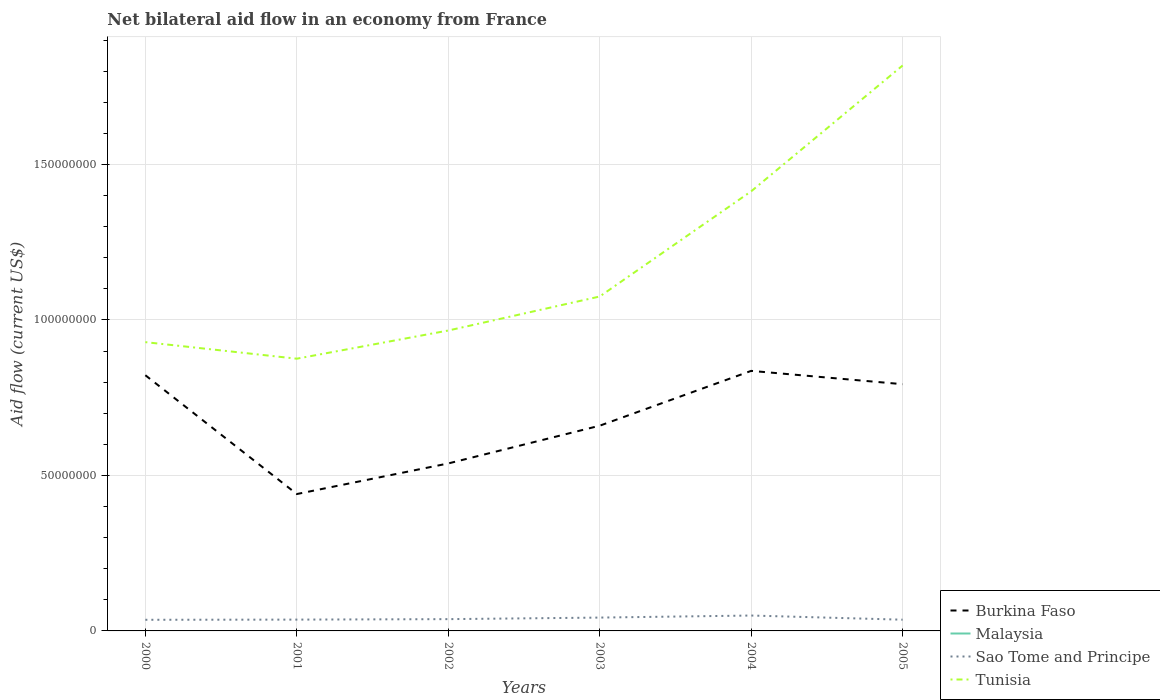How many different coloured lines are there?
Make the answer very short. 3. Is the number of lines equal to the number of legend labels?
Your response must be concise. No. Across all years, what is the maximum net bilateral aid flow in Burkina Faso?
Keep it short and to the point. 4.40e+07. What is the total net bilateral aid flow in Tunisia in the graph?
Ensure brevity in your answer.  -1.09e+07. What is the difference between the highest and the second highest net bilateral aid flow in Burkina Faso?
Provide a short and direct response. 3.96e+07. How many lines are there?
Offer a very short reply. 3. How many years are there in the graph?
Offer a terse response. 6. Does the graph contain any zero values?
Your response must be concise. Yes. Does the graph contain grids?
Make the answer very short. Yes. Where does the legend appear in the graph?
Keep it short and to the point. Bottom right. How many legend labels are there?
Your answer should be very brief. 4. How are the legend labels stacked?
Your answer should be compact. Vertical. What is the title of the graph?
Your response must be concise. Net bilateral aid flow in an economy from France. What is the label or title of the X-axis?
Keep it short and to the point. Years. What is the label or title of the Y-axis?
Your response must be concise. Aid flow (current US$). What is the Aid flow (current US$) in Burkina Faso in 2000?
Your response must be concise. 8.22e+07. What is the Aid flow (current US$) in Malaysia in 2000?
Offer a terse response. 0. What is the Aid flow (current US$) of Sao Tome and Principe in 2000?
Offer a very short reply. 3.58e+06. What is the Aid flow (current US$) in Tunisia in 2000?
Offer a terse response. 9.29e+07. What is the Aid flow (current US$) in Burkina Faso in 2001?
Your response must be concise. 4.40e+07. What is the Aid flow (current US$) in Malaysia in 2001?
Keep it short and to the point. 0. What is the Aid flow (current US$) of Sao Tome and Principe in 2001?
Ensure brevity in your answer.  3.64e+06. What is the Aid flow (current US$) of Tunisia in 2001?
Make the answer very short. 8.76e+07. What is the Aid flow (current US$) in Burkina Faso in 2002?
Keep it short and to the point. 5.39e+07. What is the Aid flow (current US$) in Malaysia in 2002?
Ensure brevity in your answer.  0. What is the Aid flow (current US$) of Sao Tome and Principe in 2002?
Provide a succinct answer. 3.79e+06. What is the Aid flow (current US$) of Tunisia in 2002?
Offer a terse response. 9.66e+07. What is the Aid flow (current US$) of Burkina Faso in 2003?
Offer a terse response. 6.60e+07. What is the Aid flow (current US$) in Malaysia in 2003?
Keep it short and to the point. 0. What is the Aid flow (current US$) of Sao Tome and Principe in 2003?
Provide a short and direct response. 4.29e+06. What is the Aid flow (current US$) of Tunisia in 2003?
Give a very brief answer. 1.08e+08. What is the Aid flow (current US$) of Burkina Faso in 2004?
Make the answer very short. 8.36e+07. What is the Aid flow (current US$) in Sao Tome and Principe in 2004?
Your response must be concise. 4.95e+06. What is the Aid flow (current US$) of Tunisia in 2004?
Your answer should be very brief. 1.41e+08. What is the Aid flow (current US$) of Burkina Faso in 2005?
Make the answer very short. 7.94e+07. What is the Aid flow (current US$) of Malaysia in 2005?
Offer a terse response. 0. What is the Aid flow (current US$) of Sao Tome and Principe in 2005?
Offer a terse response. 3.61e+06. What is the Aid flow (current US$) in Tunisia in 2005?
Make the answer very short. 1.82e+08. Across all years, what is the maximum Aid flow (current US$) of Burkina Faso?
Offer a very short reply. 8.36e+07. Across all years, what is the maximum Aid flow (current US$) of Sao Tome and Principe?
Your answer should be compact. 4.95e+06. Across all years, what is the maximum Aid flow (current US$) in Tunisia?
Keep it short and to the point. 1.82e+08. Across all years, what is the minimum Aid flow (current US$) in Burkina Faso?
Provide a succinct answer. 4.40e+07. Across all years, what is the minimum Aid flow (current US$) of Sao Tome and Principe?
Provide a succinct answer. 3.58e+06. Across all years, what is the minimum Aid flow (current US$) of Tunisia?
Offer a terse response. 8.76e+07. What is the total Aid flow (current US$) in Burkina Faso in the graph?
Your answer should be very brief. 4.09e+08. What is the total Aid flow (current US$) of Malaysia in the graph?
Your answer should be compact. 0. What is the total Aid flow (current US$) of Sao Tome and Principe in the graph?
Your response must be concise. 2.39e+07. What is the total Aid flow (current US$) of Tunisia in the graph?
Ensure brevity in your answer.  7.08e+08. What is the difference between the Aid flow (current US$) in Burkina Faso in 2000 and that in 2001?
Keep it short and to the point. 3.82e+07. What is the difference between the Aid flow (current US$) in Sao Tome and Principe in 2000 and that in 2001?
Ensure brevity in your answer.  -6.00e+04. What is the difference between the Aid flow (current US$) of Tunisia in 2000 and that in 2001?
Ensure brevity in your answer.  5.32e+06. What is the difference between the Aid flow (current US$) in Burkina Faso in 2000 and that in 2002?
Give a very brief answer. 2.84e+07. What is the difference between the Aid flow (current US$) in Tunisia in 2000 and that in 2002?
Give a very brief answer. -3.74e+06. What is the difference between the Aid flow (current US$) in Burkina Faso in 2000 and that in 2003?
Give a very brief answer. 1.62e+07. What is the difference between the Aid flow (current US$) of Sao Tome and Principe in 2000 and that in 2003?
Provide a succinct answer. -7.10e+05. What is the difference between the Aid flow (current US$) in Tunisia in 2000 and that in 2003?
Your answer should be very brief. -1.47e+07. What is the difference between the Aid flow (current US$) of Burkina Faso in 2000 and that in 2004?
Keep it short and to the point. -1.40e+06. What is the difference between the Aid flow (current US$) of Sao Tome and Principe in 2000 and that in 2004?
Give a very brief answer. -1.37e+06. What is the difference between the Aid flow (current US$) of Tunisia in 2000 and that in 2004?
Offer a terse response. -4.85e+07. What is the difference between the Aid flow (current US$) of Burkina Faso in 2000 and that in 2005?
Your response must be concise. 2.88e+06. What is the difference between the Aid flow (current US$) of Sao Tome and Principe in 2000 and that in 2005?
Make the answer very short. -3.00e+04. What is the difference between the Aid flow (current US$) in Tunisia in 2000 and that in 2005?
Provide a succinct answer. -8.90e+07. What is the difference between the Aid flow (current US$) of Burkina Faso in 2001 and that in 2002?
Provide a short and direct response. -9.84e+06. What is the difference between the Aid flow (current US$) of Sao Tome and Principe in 2001 and that in 2002?
Offer a terse response. -1.50e+05. What is the difference between the Aid flow (current US$) in Tunisia in 2001 and that in 2002?
Make the answer very short. -9.06e+06. What is the difference between the Aid flow (current US$) in Burkina Faso in 2001 and that in 2003?
Keep it short and to the point. -2.20e+07. What is the difference between the Aid flow (current US$) in Sao Tome and Principe in 2001 and that in 2003?
Your answer should be compact. -6.50e+05. What is the difference between the Aid flow (current US$) in Tunisia in 2001 and that in 2003?
Give a very brief answer. -2.00e+07. What is the difference between the Aid flow (current US$) of Burkina Faso in 2001 and that in 2004?
Provide a short and direct response. -3.96e+07. What is the difference between the Aid flow (current US$) in Sao Tome and Principe in 2001 and that in 2004?
Offer a terse response. -1.31e+06. What is the difference between the Aid flow (current US$) of Tunisia in 2001 and that in 2004?
Give a very brief answer. -5.38e+07. What is the difference between the Aid flow (current US$) in Burkina Faso in 2001 and that in 2005?
Provide a succinct answer. -3.53e+07. What is the difference between the Aid flow (current US$) of Tunisia in 2001 and that in 2005?
Your answer should be compact. -9.43e+07. What is the difference between the Aid flow (current US$) in Burkina Faso in 2002 and that in 2003?
Make the answer very short. -1.21e+07. What is the difference between the Aid flow (current US$) in Sao Tome and Principe in 2002 and that in 2003?
Give a very brief answer. -5.00e+05. What is the difference between the Aid flow (current US$) in Tunisia in 2002 and that in 2003?
Offer a terse response. -1.09e+07. What is the difference between the Aid flow (current US$) in Burkina Faso in 2002 and that in 2004?
Your response must be concise. -2.98e+07. What is the difference between the Aid flow (current US$) of Sao Tome and Principe in 2002 and that in 2004?
Provide a short and direct response. -1.16e+06. What is the difference between the Aid flow (current US$) of Tunisia in 2002 and that in 2004?
Keep it short and to the point. -4.48e+07. What is the difference between the Aid flow (current US$) of Burkina Faso in 2002 and that in 2005?
Give a very brief answer. -2.55e+07. What is the difference between the Aid flow (current US$) of Tunisia in 2002 and that in 2005?
Provide a short and direct response. -8.52e+07. What is the difference between the Aid flow (current US$) of Burkina Faso in 2003 and that in 2004?
Offer a terse response. -1.76e+07. What is the difference between the Aid flow (current US$) of Sao Tome and Principe in 2003 and that in 2004?
Keep it short and to the point. -6.60e+05. What is the difference between the Aid flow (current US$) in Tunisia in 2003 and that in 2004?
Your answer should be compact. -3.38e+07. What is the difference between the Aid flow (current US$) of Burkina Faso in 2003 and that in 2005?
Offer a very short reply. -1.34e+07. What is the difference between the Aid flow (current US$) in Sao Tome and Principe in 2003 and that in 2005?
Provide a succinct answer. 6.80e+05. What is the difference between the Aid flow (current US$) of Tunisia in 2003 and that in 2005?
Make the answer very short. -7.43e+07. What is the difference between the Aid flow (current US$) of Burkina Faso in 2004 and that in 2005?
Your answer should be very brief. 4.28e+06. What is the difference between the Aid flow (current US$) in Sao Tome and Principe in 2004 and that in 2005?
Offer a very short reply. 1.34e+06. What is the difference between the Aid flow (current US$) in Tunisia in 2004 and that in 2005?
Offer a very short reply. -4.05e+07. What is the difference between the Aid flow (current US$) of Burkina Faso in 2000 and the Aid flow (current US$) of Sao Tome and Principe in 2001?
Ensure brevity in your answer.  7.86e+07. What is the difference between the Aid flow (current US$) of Burkina Faso in 2000 and the Aid flow (current US$) of Tunisia in 2001?
Provide a short and direct response. -5.32e+06. What is the difference between the Aid flow (current US$) in Sao Tome and Principe in 2000 and the Aid flow (current US$) in Tunisia in 2001?
Provide a short and direct response. -8.40e+07. What is the difference between the Aid flow (current US$) of Burkina Faso in 2000 and the Aid flow (current US$) of Sao Tome and Principe in 2002?
Your response must be concise. 7.84e+07. What is the difference between the Aid flow (current US$) in Burkina Faso in 2000 and the Aid flow (current US$) in Tunisia in 2002?
Your answer should be compact. -1.44e+07. What is the difference between the Aid flow (current US$) in Sao Tome and Principe in 2000 and the Aid flow (current US$) in Tunisia in 2002?
Your answer should be compact. -9.30e+07. What is the difference between the Aid flow (current US$) of Burkina Faso in 2000 and the Aid flow (current US$) of Sao Tome and Principe in 2003?
Provide a succinct answer. 7.79e+07. What is the difference between the Aid flow (current US$) in Burkina Faso in 2000 and the Aid flow (current US$) in Tunisia in 2003?
Your response must be concise. -2.53e+07. What is the difference between the Aid flow (current US$) in Sao Tome and Principe in 2000 and the Aid flow (current US$) in Tunisia in 2003?
Provide a succinct answer. -1.04e+08. What is the difference between the Aid flow (current US$) in Burkina Faso in 2000 and the Aid flow (current US$) in Sao Tome and Principe in 2004?
Ensure brevity in your answer.  7.73e+07. What is the difference between the Aid flow (current US$) of Burkina Faso in 2000 and the Aid flow (current US$) of Tunisia in 2004?
Give a very brief answer. -5.92e+07. What is the difference between the Aid flow (current US$) of Sao Tome and Principe in 2000 and the Aid flow (current US$) of Tunisia in 2004?
Ensure brevity in your answer.  -1.38e+08. What is the difference between the Aid flow (current US$) of Burkina Faso in 2000 and the Aid flow (current US$) of Sao Tome and Principe in 2005?
Give a very brief answer. 7.86e+07. What is the difference between the Aid flow (current US$) in Burkina Faso in 2000 and the Aid flow (current US$) in Tunisia in 2005?
Offer a terse response. -9.96e+07. What is the difference between the Aid flow (current US$) of Sao Tome and Principe in 2000 and the Aid flow (current US$) of Tunisia in 2005?
Give a very brief answer. -1.78e+08. What is the difference between the Aid flow (current US$) of Burkina Faso in 2001 and the Aid flow (current US$) of Sao Tome and Principe in 2002?
Keep it short and to the point. 4.02e+07. What is the difference between the Aid flow (current US$) in Burkina Faso in 2001 and the Aid flow (current US$) in Tunisia in 2002?
Your response must be concise. -5.26e+07. What is the difference between the Aid flow (current US$) of Sao Tome and Principe in 2001 and the Aid flow (current US$) of Tunisia in 2002?
Make the answer very short. -9.30e+07. What is the difference between the Aid flow (current US$) of Burkina Faso in 2001 and the Aid flow (current US$) of Sao Tome and Principe in 2003?
Offer a terse response. 3.97e+07. What is the difference between the Aid flow (current US$) of Burkina Faso in 2001 and the Aid flow (current US$) of Tunisia in 2003?
Make the answer very short. -6.35e+07. What is the difference between the Aid flow (current US$) in Sao Tome and Principe in 2001 and the Aid flow (current US$) in Tunisia in 2003?
Your response must be concise. -1.04e+08. What is the difference between the Aid flow (current US$) of Burkina Faso in 2001 and the Aid flow (current US$) of Sao Tome and Principe in 2004?
Your response must be concise. 3.91e+07. What is the difference between the Aid flow (current US$) of Burkina Faso in 2001 and the Aid flow (current US$) of Tunisia in 2004?
Ensure brevity in your answer.  -9.74e+07. What is the difference between the Aid flow (current US$) of Sao Tome and Principe in 2001 and the Aid flow (current US$) of Tunisia in 2004?
Offer a terse response. -1.38e+08. What is the difference between the Aid flow (current US$) of Burkina Faso in 2001 and the Aid flow (current US$) of Sao Tome and Principe in 2005?
Your answer should be compact. 4.04e+07. What is the difference between the Aid flow (current US$) of Burkina Faso in 2001 and the Aid flow (current US$) of Tunisia in 2005?
Offer a terse response. -1.38e+08. What is the difference between the Aid flow (current US$) of Sao Tome and Principe in 2001 and the Aid flow (current US$) of Tunisia in 2005?
Offer a terse response. -1.78e+08. What is the difference between the Aid flow (current US$) in Burkina Faso in 2002 and the Aid flow (current US$) in Sao Tome and Principe in 2003?
Ensure brevity in your answer.  4.96e+07. What is the difference between the Aid flow (current US$) of Burkina Faso in 2002 and the Aid flow (current US$) of Tunisia in 2003?
Your response must be concise. -5.37e+07. What is the difference between the Aid flow (current US$) of Sao Tome and Principe in 2002 and the Aid flow (current US$) of Tunisia in 2003?
Ensure brevity in your answer.  -1.04e+08. What is the difference between the Aid flow (current US$) of Burkina Faso in 2002 and the Aid flow (current US$) of Sao Tome and Principe in 2004?
Provide a succinct answer. 4.89e+07. What is the difference between the Aid flow (current US$) of Burkina Faso in 2002 and the Aid flow (current US$) of Tunisia in 2004?
Offer a very short reply. -8.75e+07. What is the difference between the Aid flow (current US$) in Sao Tome and Principe in 2002 and the Aid flow (current US$) in Tunisia in 2004?
Make the answer very short. -1.38e+08. What is the difference between the Aid flow (current US$) in Burkina Faso in 2002 and the Aid flow (current US$) in Sao Tome and Principe in 2005?
Your answer should be very brief. 5.02e+07. What is the difference between the Aid flow (current US$) of Burkina Faso in 2002 and the Aid flow (current US$) of Tunisia in 2005?
Your response must be concise. -1.28e+08. What is the difference between the Aid flow (current US$) of Sao Tome and Principe in 2002 and the Aid flow (current US$) of Tunisia in 2005?
Keep it short and to the point. -1.78e+08. What is the difference between the Aid flow (current US$) in Burkina Faso in 2003 and the Aid flow (current US$) in Sao Tome and Principe in 2004?
Provide a short and direct response. 6.10e+07. What is the difference between the Aid flow (current US$) of Burkina Faso in 2003 and the Aid flow (current US$) of Tunisia in 2004?
Offer a very short reply. -7.54e+07. What is the difference between the Aid flow (current US$) in Sao Tome and Principe in 2003 and the Aid flow (current US$) in Tunisia in 2004?
Ensure brevity in your answer.  -1.37e+08. What is the difference between the Aid flow (current US$) in Burkina Faso in 2003 and the Aid flow (current US$) in Sao Tome and Principe in 2005?
Make the answer very short. 6.24e+07. What is the difference between the Aid flow (current US$) of Burkina Faso in 2003 and the Aid flow (current US$) of Tunisia in 2005?
Your answer should be compact. -1.16e+08. What is the difference between the Aid flow (current US$) of Sao Tome and Principe in 2003 and the Aid flow (current US$) of Tunisia in 2005?
Offer a very short reply. -1.78e+08. What is the difference between the Aid flow (current US$) of Burkina Faso in 2004 and the Aid flow (current US$) of Sao Tome and Principe in 2005?
Keep it short and to the point. 8.00e+07. What is the difference between the Aid flow (current US$) of Burkina Faso in 2004 and the Aid flow (current US$) of Tunisia in 2005?
Your answer should be very brief. -9.82e+07. What is the difference between the Aid flow (current US$) in Sao Tome and Principe in 2004 and the Aid flow (current US$) in Tunisia in 2005?
Make the answer very short. -1.77e+08. What is the average Aid flow (current US$) of Burkina Faso per year?
Your answer should be very brief. 6.82e+07. What is the average Aid flow (current US$) of Sao Tome and Principe per year?
Offer a very short reply. 3.98e+06. What is the average Aid flow (current US$) of Tunisia per year?
Keep it short and to the point. 1.18e+08. In the year 2000, what is the difference between the Aid flow (current US$) in Burkina Faso and Aid flow (current US$) in Sao Tome and Principe?
Your response must be concise. 7.86e+07. In the year 2000, what is the difference between the Aid flow (current US$) of Burkina Faso and Aid flow (current US$) of Tunisia?
Provide a succinct answer. -1.06e+07. In the year 2000, what is the difference between the Aid flow (current US$) in Sao Tome and Principe and Aid flow (current US$) in Tunisia?
Provide a succinct answer. -8.93e+07. In the year 2001, what is the difference between the Aid flow (current US$) in Burkina Faso and Aid flow (current US$) in Sao Tome and Principe?
Ensure brevity in your answer.  4.04e+07. In the year 2001, what is the difference between the Aid flow (current US$) in Burkina Faso and Aid flow (current US$) in Tunisia?
Ensure brevity in your answer.  -4.35e+07. In the year 2001, what is the difference between the Aid flow (current US$) of Sao Tome and Principe and Aid flow (current US$) of Tunisia?
Your response must be concise. -8.39e+07. In the year 2002, what is the difference between the Aid flow (current US$) in Burkina Faso and Aid flow (current US$) in Sao Tome and Principe?
Keep it short and to the point. 5.01e+07. In the year 2002, what is the difference between the Aid flow (current US$) in Burkina Faso and Aid flow (current US$) in Tunisia?
Ensure brevity in your answer.  -4.28e+07. In the year 2002, what is the difference between the Aid flow (current US$) in Sao Tome and Principe and Aid flow (current US$) in Tunisia?
Your answer should be compact. -9.28e+07. In the year 2003, what is the difference between the Aid flow (current US$) of Burkina Faso and Aid flow (current US$) of Sao Tome and Principe?
Give a very brief answer. 6.17e+07. In the year 2003, what is the difference between the Aid flow (current US$) of Burkina Faso and Aid flow (current US$) of Tunisia?
Offer a terse response. -4.16e+07. In the year 2003, what is the difference between the Aid flow (current US$) in Sao Tome and Principe and Aid flow (current US$) in Tunisia?
Your response must be concise. -1.03e+08. In the year 2004, what is the difference between the Aid flow (current US$) of Burkina Faso and Aid flow (current US$) of Sao Tome and Principe?
Ensure brevity in your answer.  7.87e+07. In the year 2004, what is the difference between the Aid flow (current US$) of Burkina Faso and Aid flow (current US$) of Tunisia?
Provide a succinct answer. -5.78e+07. In the year 2004, what is the difference between the Aid flow (current US$) of Sao Tome and Principe and Aid flow (current US$) of Tunisia?
Your answer should be very brief. -1.36e+08. In the year 2005, what is the difference between the Aid flow (current US$) of Burkina Faso and Aid flow (current US$) of Sao Tome and Principe?
Ensure brevity in your answer.  7.57e+07. In the year 2005, what is the difference between the Aid flow (current US$) in Burkina Faso and Aid flow (current US$) in Tunisia?
Provide a succinct answer. -1.02e+08. In the year 2005, what is the difference between the Aid flow (current US$) in Sao Tome and Principe and Aid flow (current US$) in Tunisia?
Provide a short and direct response. -1.78e+08. What is the ratio of the Aid flow (current US$) in Burkina Faso in 2000 to that in 2001?
Ensure brevity in your answer.  1.87. What is the ratio of the Aid flow (current US$) of Sao Tome and Principe in 2000 to that in 2001?
Your response must be concise. 0.98. What is the ratio of the Aid flow (current US$) of Tunisia in 2000 to that in 2001?
Offer a terse response. 1.06. What is the ratio of the Aid flow (current US$) of Burkina Faso in 2000 to that in 2002?
Provide a succinct answer. 1.53. What is the ratio of the Aid flow (current US$) of Sao Tome and Principe in 2000 to that in 2002?
Offer a very short reply. 0.94. What is the ratio of the Aid flow (current US$) of Tunisia in 2000 to that in 2002?
Your answer should be very brief. 0.96. What is the ratio of the Aid flow (current US$) of Burkina Faso in 2000 to that in 2003?
Provide a short and direct response. 1.25. What is the ratio of the Aid flow (current US$) in Sao Tome and Principe in 2000 to that in 2003?
Your answer should be compact. 0.83. What is the ratio of the Aid flow (current US$) of Tunisia in 2000 to that in 2003?
Your response must be concise. 0.86. What is the ratio of the Aid flow (current US$) of Burkina Faso in 2000 to that in 2004?
Provide a short and direct response. 0.98. What is the ratio of the Aid flow (current US$) of Sao Tome and Principe in 2000 to that in 2004?
Keep it short and to the point. 0.72. What is the ratio of the Aid flow (current US$) of Tunisia in 2000 to that in 2004?
Provide a succinct answer. 0.66. What is the ratio of the Aid flow (current US$) in Burkina Faso in 2000 to that in 2005?
Give a very brief answer. 1.04. What is the ratio of the Aid flow (current US$) in Tunisia in 2000 to that in 2005?
Offer a terse response. 0.51. What is the ratio of the Aid flow (current US$) in Burkina Faso in 2001 to that in 2002?
Make the answer very short. 0.82. What is the ratio of the Aid flow (current US$) in Sao Tome and Principe in 2001 to that in 2002?
Ensure brevity in your answer.  0.96. What is the ratio of the Aid flow (current US$) of Tunisia in 2001 to that in 2002?
Your response must be concise. 0.91. What is the ratio of the Aid flow (current US$) of Burkina Faso in 2001 to that in 2003?
Ensure brevity in your answer.  0.67. What is the ratio of the Aid flow (current US$) in Sao Tome and Principe in 2001 to that in 2003?
Make the answer very short. 0.85. What is the ratio of the Aid flow (current US$) in Tunisia in 2001 to that in 2003?
Make the answer very short. 0.81. What is the ratio of the Aid flow (current US$) of Burkina Faso in 2001 to that in 2004?
Make the answer very short. 0.53. What is the ratio of the Aid flow (current US$) of Sao Tome and Principe in 2001 to that in 2004?
Ensure brevity in your answer.  0.74. What is the ratio of the Aid flow (current US$) of Tunisia in 2001 to that in 2004?
Offer a very short reply. 0.62. What is the ratio of the Aid flow (current US$) of Burkina Faso in 2001 to that in 2005?
Give a very brief answer. 0.55. What is the ratio of the Aid flow (current US$) of Sao Tome and Principe in 2001 to that in 2005?
Offer a terse response. 1.01. What is the ratio of the Aid flow (current US$) in Tunisia in 2001 to that in 2005?
Offer a terse response. 0.48. What is the ratio of the Aid flow (current US$) of Burkina Faso in 2002 to that in 2003?
Your answer should be very brief. 0.82. What is the ratio of the Aid flow (current US$) of Sao Tome and Principe in 2002 to that in 2003?
Ensure brevity in your answer.  0.88. What is the ratio of the Aid flow (current US$) of Tunisia in 2002 to that in 2003?
Your answer should be very brief. 0.9. What is the ratio of the Aid flow (current US$) of Burkina Faso in 2002 to that in 2004?
Your response must be concise. 0.64. What is the ratio of the Aid flow (current US$) in Sao Tome and Principe in 2002 to that in 2004?
Ensure brevity in your answer.  0.77. What is the ratio of the Aid flow (current US$) in Tunisia in 2002 to that in 2004?
Ensure brevity in your answer.  0.68. What is the ratio of the Aid flow (current US$) in Burkina Faso in 2002 to that in 2005?
Provide a succinct answer. 0.68. What is the ratio of the Aid flow (current US$) in Sao Tome and Principe in 2002 to that in 2005?
Your response must be concise. 1.05. What is the ratio of the Aid flow (current US$) in Tunisia in 2002 to that in 2005?
Provide a short and direct response. 0.53. What is the ratio of the Aid flow (current US$) in Burkina Faso in 2003 to that in 2004?
Make the answer very short. 0.79. What is the ratio of the Aid flow (current US$) in Sao Tome and Principe in 2003 to that in 2004?
Provide a succinct answer. 0.87. What is the ratio of the Aid flow (current US$) of Tunisia in 2003 to that in 2004?
Provide a short and direct response. 0.76. What is the ratio of the Aid flow (current US$) in Burkina Faso in 2003 to that in 2005?
Provide a succinct answer. 0.83. What is the ratio of the Aid flow (current US$) of Sao Tome and Principe in 2003 to that in 2005?
Ensure brevity in your answer.  1.19. What is the ratio of the Aid flow (current US$) of Tunisia in 2003 to that in 2005?
Make the answer very short. 0.59. What is the ratio of the Aid flow (current US$) of Burkina Faso in 2004 to that in 2005?
Make the answer very short. 1.05. What is the ratio of the Aid flow (current US$) of Sao Tome and Principe in 2004 to that in 2005?
Offer a terse response. 1.37. What is the ratio of the Aid flow (current US$) of Tunisia in 2004 to that in 2005?
Your response must be concise. 0.78. What is the difference between the highest and the second highest Aid flow (current US$) of Burkina Faso?
Offer a very short reply. 1.40e+06. What is the difference between the highest and the second highest Aid flow (current US$) in Tunisia?
Your answer should be very brief. 4.05e+07. What is the difference between the highest and the lowest Aid flow (current US$) in Burkina Faso?
Your answer should be very brief. 3.96e+07. What is the difference between the highest and the lowest Aid flow (current US$) in Sao Tome and Principe?
Keep it short and to the point. 1.37e+06. What is the difference between the highest and the lowest Aid flow (current US$) of Tunisia?
Your answer should be compact. 9.43e+07. 